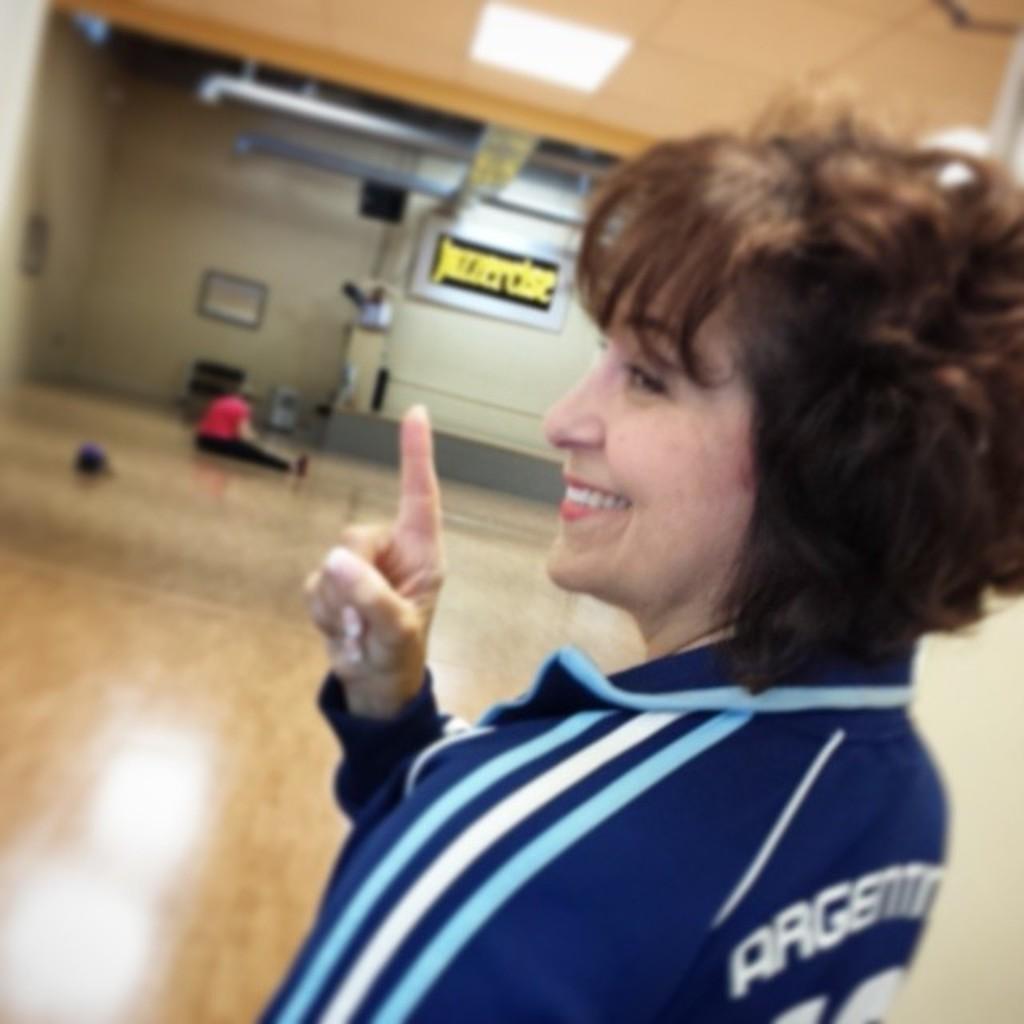Can you describe this image briefly? In this picture we can see a woman is smiling in the front, there is a person sitting in the middle, in the background we can see a wall, two metal rods and two boards, there is some text on this board, we can see a light at the top of the picture. 